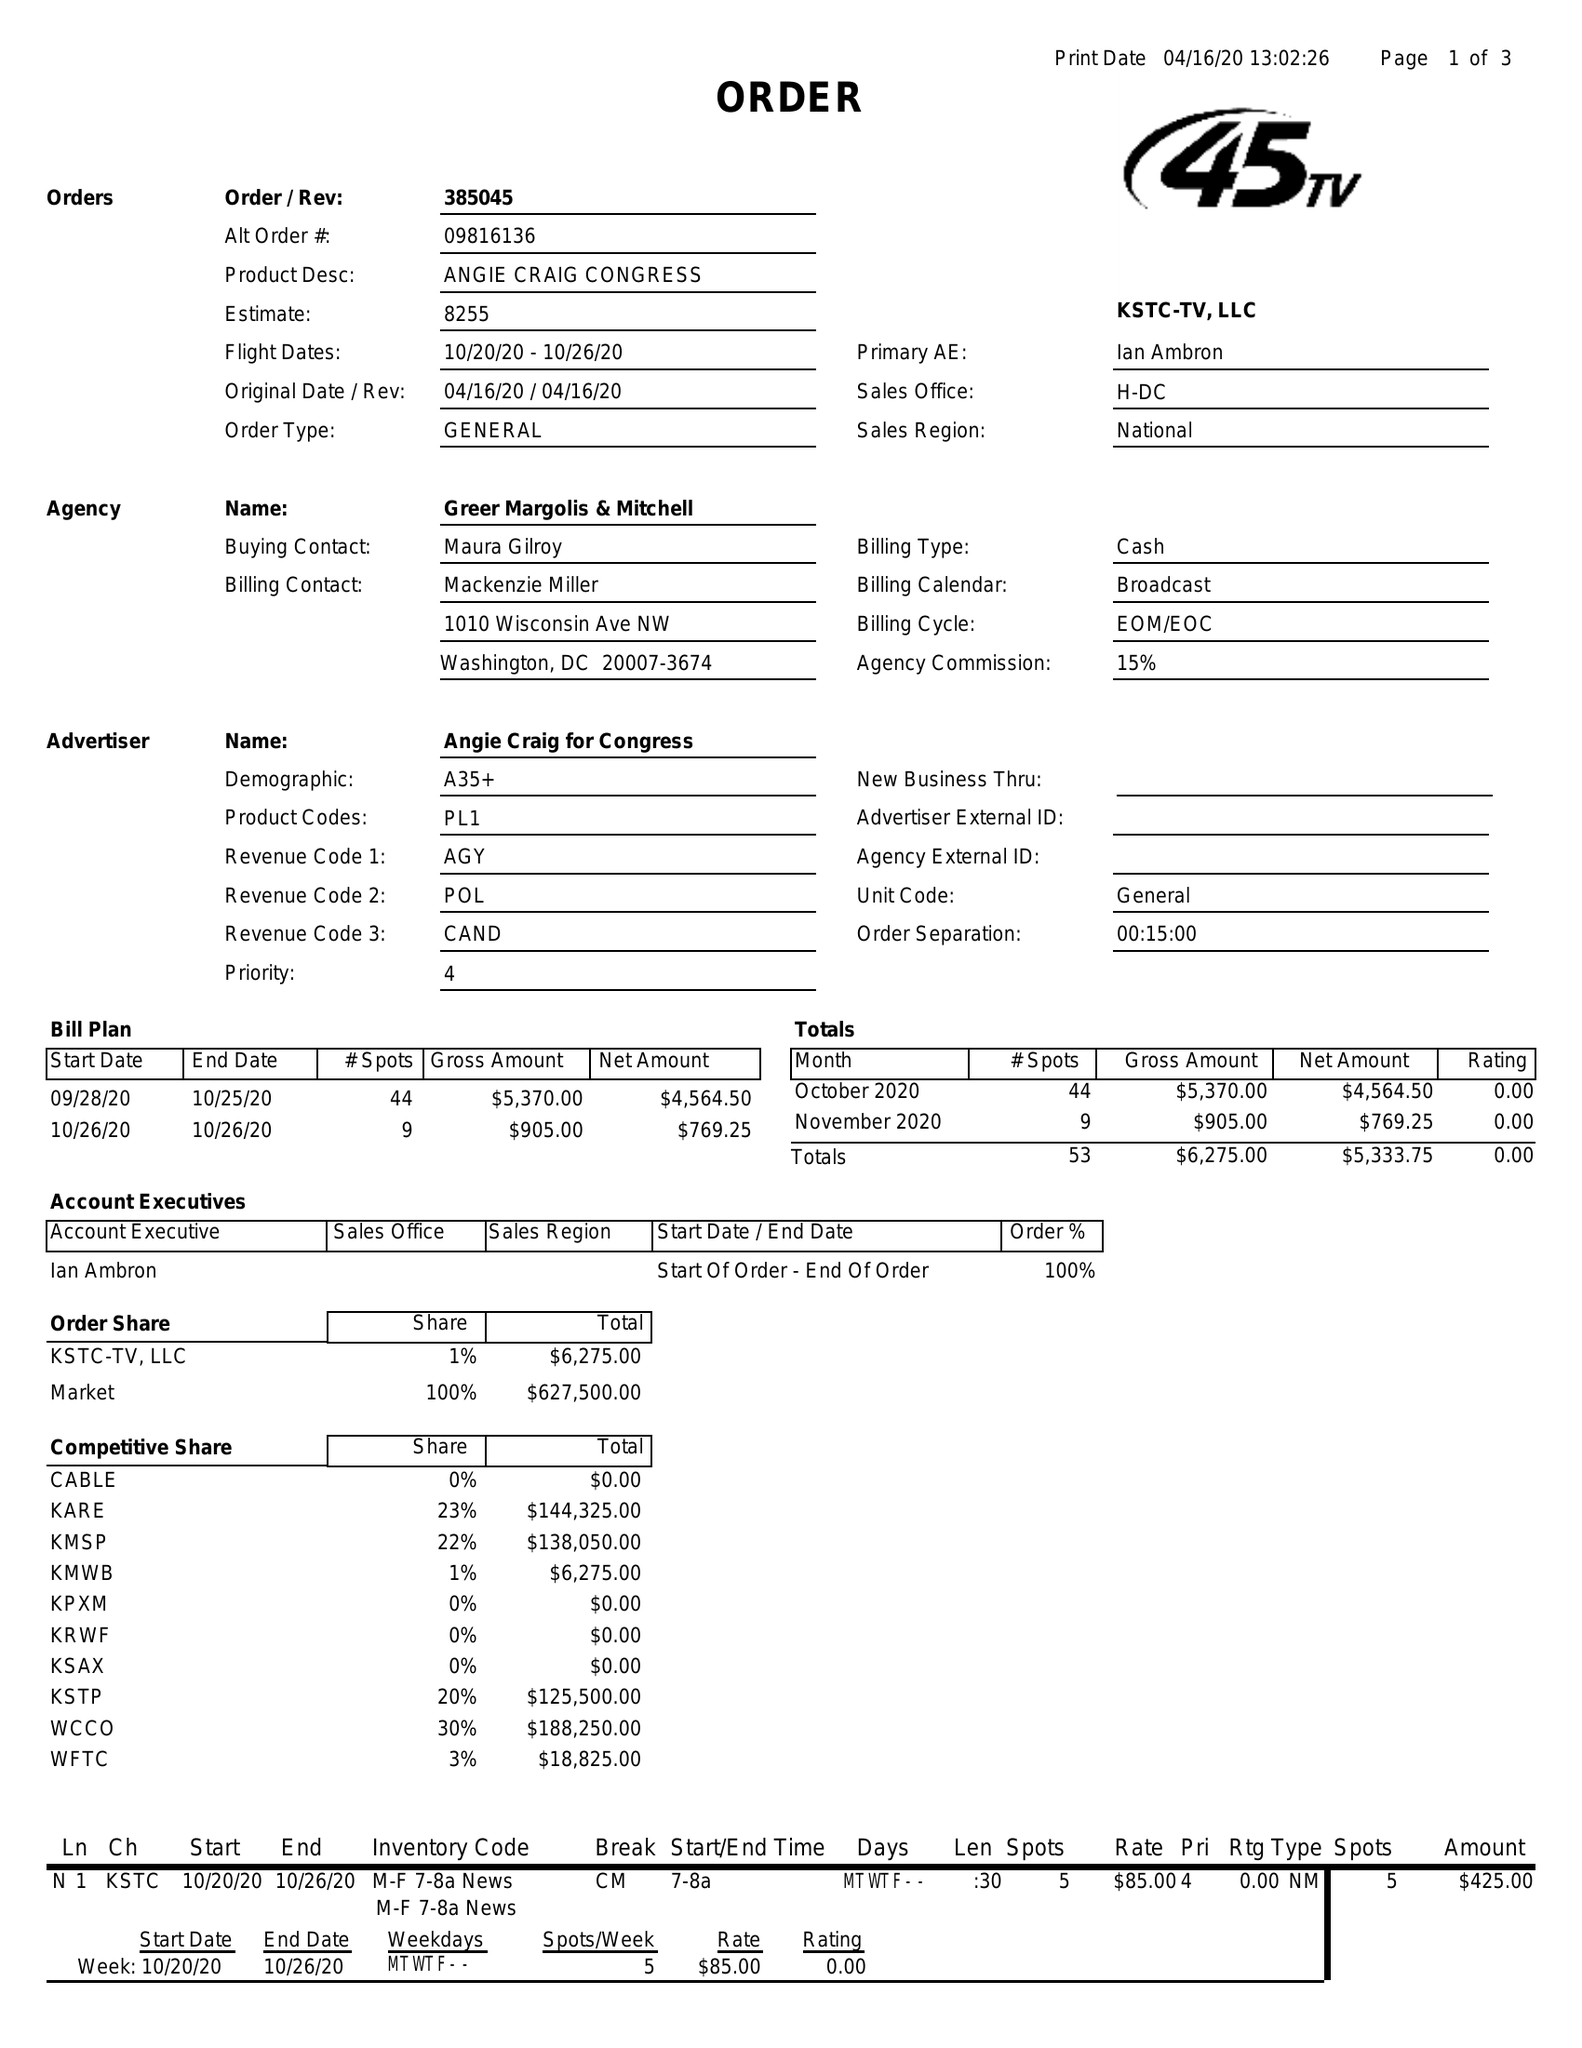What is the value for the flight_from?
Answer the question using a single word or phrase. 10/20/20 